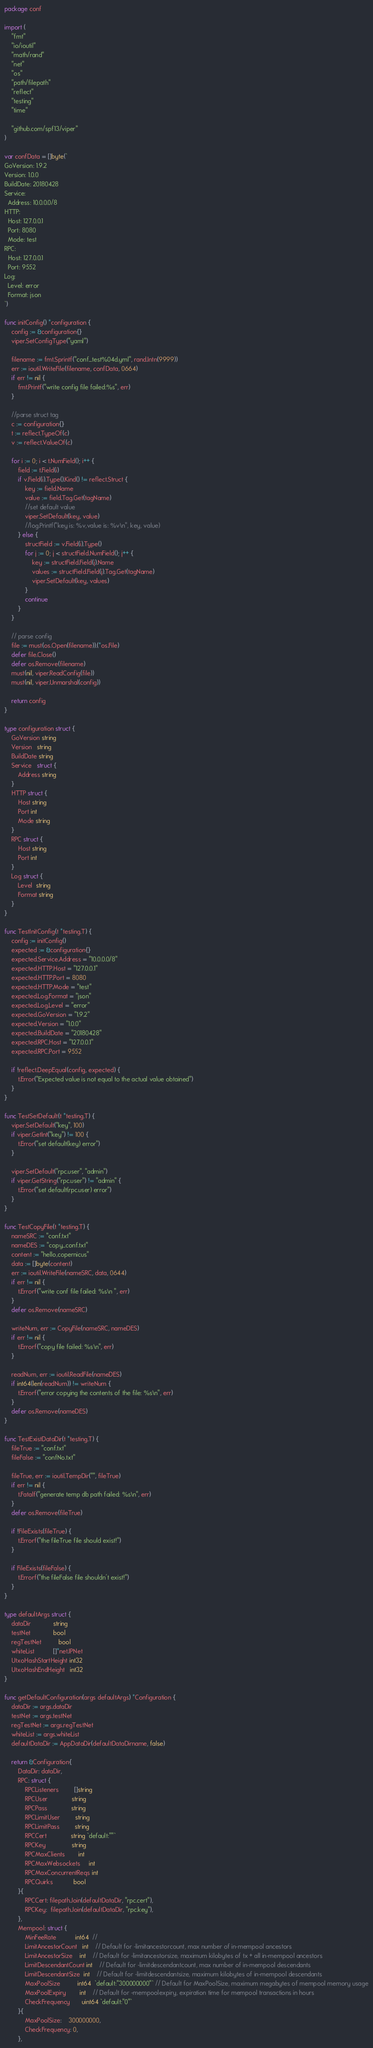Convert code to text. <code><loc_0><loc_0><loc_500><loc_500><_Go_>package conf

import (
	"fmt"
	"io/ioutil"
	"math/rand"
	"net"
	"os"
	"path/filepath"
	"reflect"
	"testing"
	"time"

	"github.com/spf13/viper"
)

var confData = []byte(`
GoVersion: 1.9.2
Version: 1.0.0
BuildDate: 20180428
Service:
  Address: 10.0.0.0/8
HTTP:
  Host: 127.0.0.1
  Port: 8080
  Mode: test
RPC:
  Host: 127.0.0.1
  Port: 9552
Log:
  Level: error
  Format: json
`)

func initConfig() *configuration {
	config := &configuration{}
	viper.SetConfigType("yaml")

	filename := fmt.Sprintf("conf_test%04d.yml", rand.Intn(9999))
	err := ioutil.WriteFile(filename, confData, 0664)
	if err != nil {
		fmt.Printf("write config file failed:%s", err)
	}

	//parse struct tag
	c := configuration{}
	t := reflect.TypeOf(c)
	v := reflect.ValueOf(c)

	for i := 0; i < t.NumField(); i++ {
		field := t.Field(i)
		if v.Field(i).Type().Kind() != reflect.Struct {
			key := field.Name
			value := field.Tag.Get(tagName)
			//set default value
			viper.SetDefault(key, value)
			//log.Printf("key is: %v,value is: %v\n", key, value)
		} else {
			structField := v.Field(i).Type()
			for j := 0; j < structField.NumField(); j++ {
				key := structField.Field(j).Name
				values := structField.Field(j).Tag.Get(tagName)
				viper.SetDefault(key, values)
			}
			continue
		}
	}

	// parse config
	file := must(os.Open(filename)).(*os.File)
	defer file.Close()
	defer os.Remove(filename)
	must(nil, viper.ReadConfig(file))
	must(nil, viper.Unmarshal(config))

	return config
}

type configuration struct {
	GoVersion string
	Version   string
	BuildDate string
	Service   struct {
		Address string
	}
	HTTP struct {
		Host string
		Port int
		Mode string
	}
	RPC struct {
		Host string
		Port int
	}
	Log struct {
		Level  string
		Format string
	}
}

func TestInitConfig(t *testing.T) {
	config := initConfig()
	expected := &configuration{}
	expected.Service.Address = "10.0.0.0/8"
	expected.HTTP.Host = "127.0.0.1"
	expected.HTTP.Port = 8080
	expected.HTTP.Mode = "test"
	expected.Log.Format = "json"
	expected.Log.Level = "error"
	expected.GoVersion = "1.9.2"
	expected.Version = "1.0.0"
	expected.BuildDate = "20180428"
	expected.RPC.Host = "127.0.0.1"
	expected.RPC.Port = 9552

	if !reflect.DeepEqual(config, expected) {
		t.Error("Expected value is not equal to the actual value obtained")
	}
}

func TestSetDefault(t *testing.T) {
	viper.SetDefault("key", 100)
	if viper.GetInt("key") != 100 {
		t.Error("set default(key) error")
	}

	viper.SetDefault("rpc.user", "admin")
	if viper.GetString("rpc.user") != "admin" {
		t.Error("set default(rpc.user) error")
	}
}

func TestCopyFile(t *testing.T) {
	nameSRC := "conf.txt"
	nameDES := "copy_conf.txt"
	content := "hello,copernicus"
	data := []byte(content)
	err := ioutil.WriteFile(nameSRC, data, 0644)
	if err != nil {
		t.Errorf("write conf file failed: %s\n ", err)
	}
	defer os.Remove(nameSRC)

	writeNum, err := CopyFile(nameSRC, nameDES)
	if err != nil {
		t.Errorf("copy file failed: %s\n", err)
	}

	readNum, err := ioutil.ReadFile(nameDES)
	if int64(len(readNum)) != writeNum {
		t.Errorf("error copying the contents of the file: %s\n", err)
	}
	defer os.Remove(nameDES)
}

func TestExistDataDir(t *testing.T) {
	fileTrue := "conf.txt"
	fileFalse := "confNo.txt"

	fileTrue, err := ioutil.TempDir("", fileTrue)
	if err != nil {
		t.Fatalf("generate temp db path failed: %s\n", err)
	}
	defer os.Remove(fileTrue)

	if !FileExists(fileTrue) {
		t.Errorf("the fileTrue file should exist!")
	}

	if FileExists(fileFalse) {
		t.Errorf("the fileFalse file shouldn't exist!")
	}
}

type defaultArgs struct {
	dataDir             string
	testNet             bool
	regTestNet          bool
	whiteList           []*net.IPNet
	UtxoHashStartHeight int32
	UtxoHashEndHeight   int32
}

func getDefaultConfiguration(args defaultArgs) *Configuration {
	dataDir := args.dataDir
	testNet := args.testNet
	regTestNet := args.regTestNet
	whiteList := args.whiteList
	defaultDataDir := AppDataDir(defaultDataDirname, false)

	return &Configuration{
		DataDir: dataDir,
		RPC: struct {
			RPCListeners         []string
			RPCUser              string
			RPCPass              string
			RPCLimitUser         string
			RPCLimitPass         string
			RPCCert              string `default:""`
			RPCKey               string
			RPCMaxClients        int
			RPCMaxWebsockets     int
			RPCMaxConcurrentReqs int
			RPCQuirks            bool
		}{
			RPCCert: filepath.Join(defaultDataDir, "rpc.cert"),
			RPCKey:  filepath.Join(defaultDataDir, "rpc.key"),
		},
		Mempool: struct {
			MinFeeRate           int64  //
			LimitAncestorCount   int    // Default for -limitancestorcount, max number of in-mempool ancestors
			LimitAncestorSize    int    // Default for -limitancestorsize, maximum kilobytes of tx + all in-mempool ancestors
			LimitDescendantCount int    // Default for -limitdescendantcount, max number of in-mempool descendants
			LimitDescendantSize  int    // Default for -limitdescendantsize, maximum kilobytes of in-mempool descendants
			MaxPoolSize          int64  `default:"300000000"` // Default for MaxPoolSize, maximum megabytes of mempool memory usage
			MaxPoolExpiry        int    // Default for -mempoolexpiry, expiration time for mempool transactions in hours
			CheckFrequency       uint64 `default:"0"`
		}{
			MaxPoolSize:    300000000,
			CheckFrequency: 0,
		},</code> 